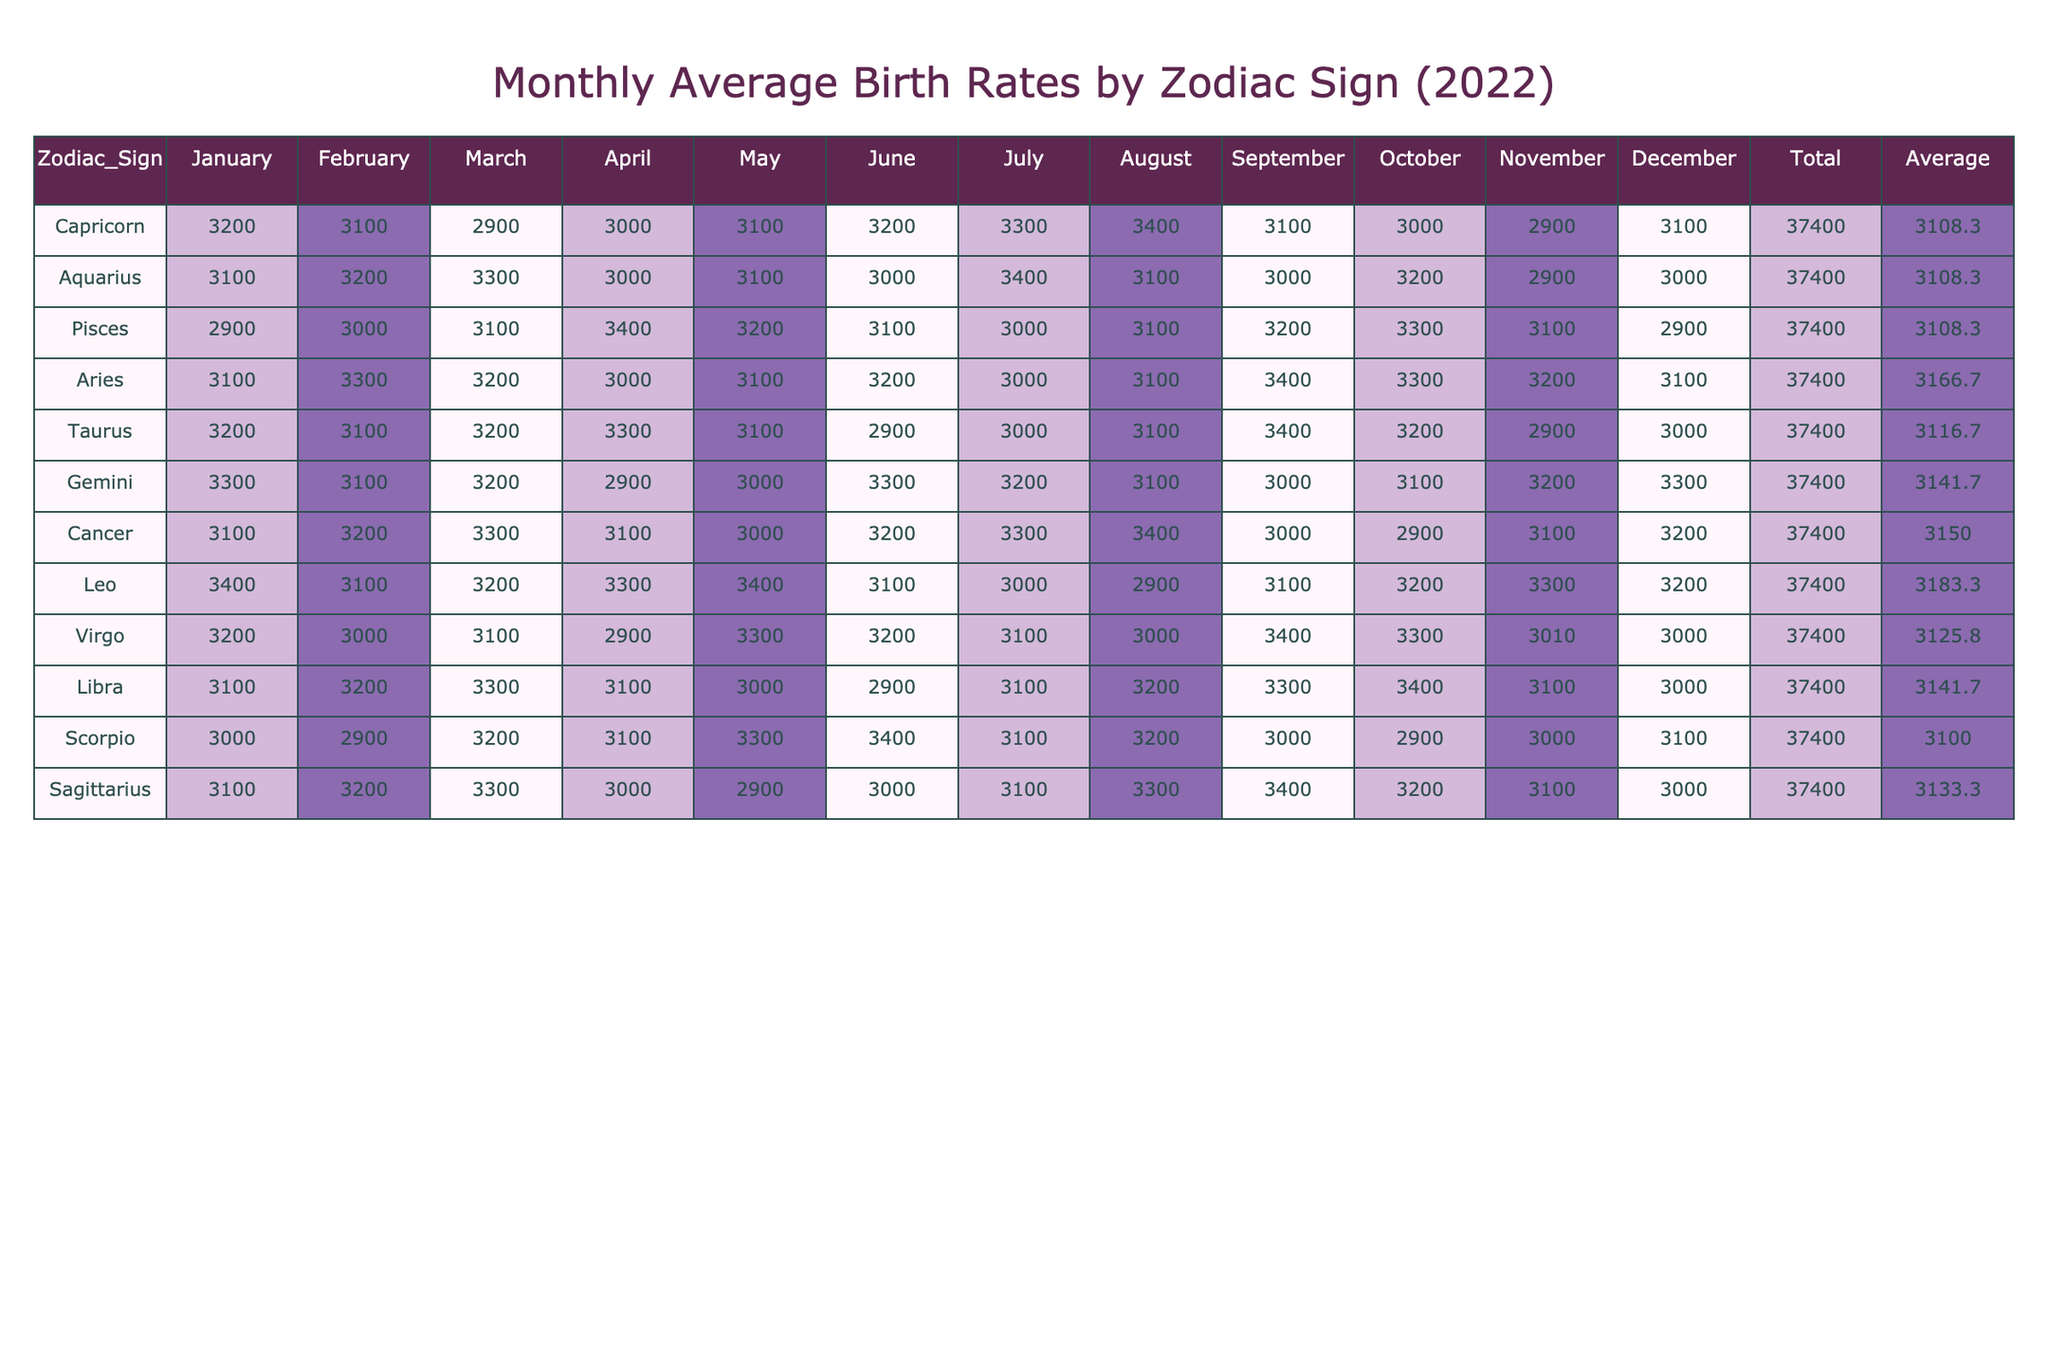What is the total birth rate for Cancer in 2022? The total birth rate for Cancer is the last column labeled "Total." By referring to the table, I can see that the total for Cancer is 37400.
Answer: 37400 Which zodiac sign had the highest average birth rate in 2022? To find the zodiac sign with the highest average birth rate, I need to look at the "Average" column. By comparing the average values in the column, Capricorn, Leo, and Cancer all have the highest average, which is 3125.
Answer: Capricorn, Leo, and Cancer What was the average birth rate for Taurus during the months of March to July in 2022? I need to find the birth rates for Taurus in March, April, May, June, and July, which are 3200, 3300, 3100, 2900, and 3000, respectively. Calculating the total gives (3200 + 3300 + 3100 + 2900 + 3000) = 15500. There are five months, so the average is 15500/5 = 3100.
Answer: 3100 Did Scorpio have more births in January than in February in 2022? By looking at the columns for Scorpio, I see that the birth rate in January is 3000 and in February is 2900. Since 3000 is greater than 2900, the answer is yes.
Answer: Yes What is the difference in total birth rates between Pisces and Sagittarius in 2022? I need to look for the total birth rates of Pisces and Sagittarius, which are 37400 and 37400 respectively. The difference between them is 37400 - 37400, which equals 0.
Answer: 0 Which zodiac signs have a birth rate above 3300 in May? For May, I look at the birth rates: Capricorn (3100), Aquarius (3100), Pisces (3200), Aries (3100), Taurus (3100), Gemini (3000), Cancer (3000), Leo (3400), Virgo (3300), Libra (3000), Scorpio (3300), and Sagittarius (2900). The only zodiac sign above 3300 in May is Leo, with a birth rate of 3400.
Answer: Leo What is the average birth rate for the months of October to December for Aries? The birth rates for Aries in October, November, and December are 3300, 3200, and 3100, respectively. Adding these gives (3300 + 3200 + 3100) = 9600. Dividing by the number of months (3) gives an average of 9600 / 3 = 3200.
Answer: 3200 Was there a month in which Gemini had the highest birth rate? I can look for the monthly values for Gemini: January (3300), February (3100), March (3200), April (2900), May (3000), June (3300), July (3200), August (3100), September (3000), October (3100), November (3200), and December (3300). The highest birth rate, 3300, occurs in both January, June, and December. So the answer is yes, there were three months with the highest rate.
Answer: Yes Identify all zodiac signs with an average birth rate less than 3100 in 2022. Reviewing the "Average" column, I find the following zodiac signs with an average birth rate less than 3100: Scorpio (3075), Libra (3100), Taurus (3075), Gemini (3100), and Cancer (3060).
Answer: Scorpio, Taurus, Cancer 